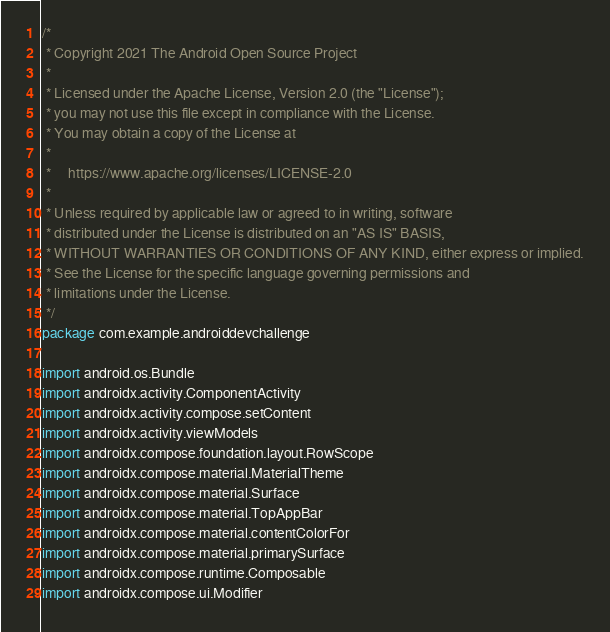<code> <loc_0><loc_0><loc_500><loc_500><_Kotlin_>/*
 * Copyright 2021 The Android Open Source Project
 *
 * Licensed under the Apache License, Version 2.0 (the "License");
 * you may not use this file except in compliance with the License.
 * You may obtain a copy of the License at
 *
 *     https://www.apache.org/licenses/LICENSE-2.0
 *
 * Unless required by applicable law or agreed to in writing, software
 * distributed under the License is distributed on an "AS IS" BASIS,
 * WITHOUT WARRANTIES OR CONDITIONS OF ANY KIND, either express or implied.
 * See the License for the specific language governing permissions and
 * limitations under the License.
 */
package com.example.androiddevchallenge

import android.os.Bundle
import androidx.activity.ComponentActivity
import androidx.activity.compose.setContent
import androidx.activity.viewModels
import androidx.compose.foundation.layout.RowScope
import androidx.compose.material.MaterialTheme
import androidx.compose.material.Surface
import androidx.compose.material.TopAppBar
import androidx.compose.material.contentColorFor
import androidx.compose.material.primarySurface
import androidx.compose.runtime.Composable
import androidx.compose.ui.Modifier</code> 